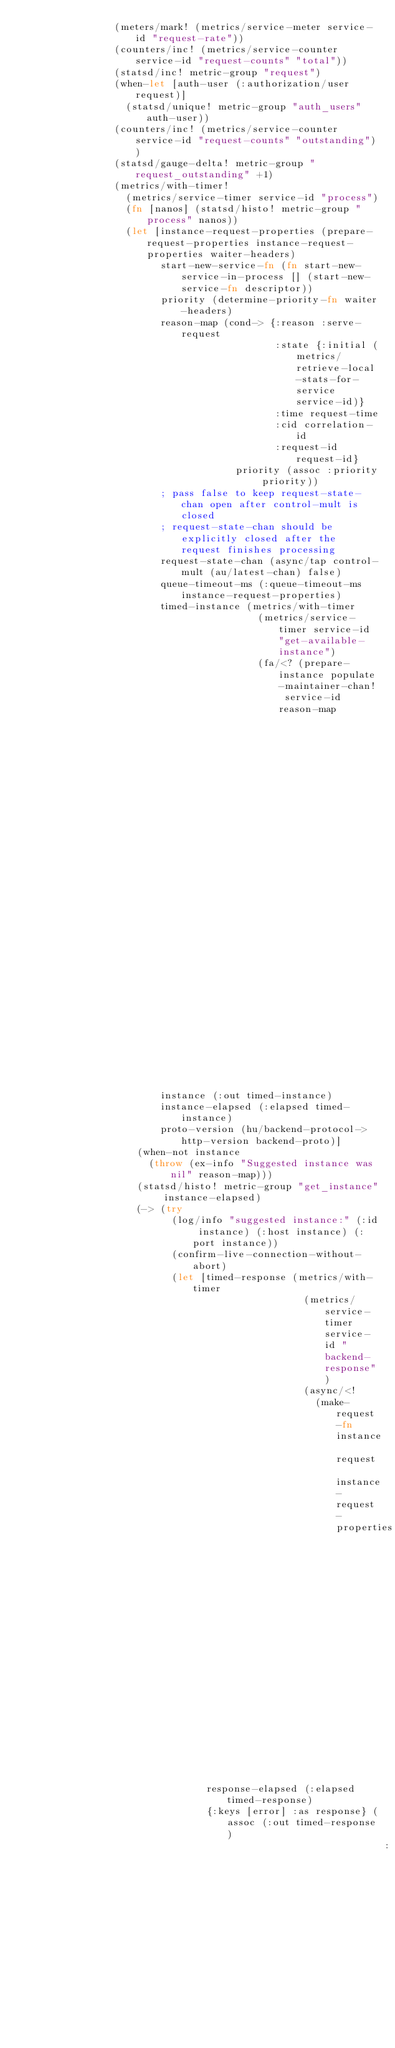<code> <loc_0><loc_0><loc_500><loc_500><_Clojure_>                (meters/mark! (metrics/service-meter service-id "request-rate"))
                (counters/inc! (metrics/service-counter service-id "request-counts" "total"))
                (statsd/inc! metric-group "request")
                (when-let [auth-user (:authorization/user request)]
                  (statsd/unique! metric-group "auth_users" auth-user))
                (counters/inc! (metrics/service-counter service-id "request-counts" "outstanding"))
                (statsd/gauge-delta! metric-group "request_outstanding" +1)
                (metrics/with-timer!
                  (metrics/service-timer service-id "process")
                  (fn [nanos] (statsd/histo! metric-group "process" nanos))
                  (let [instance-request-properties (prepare-request-properties instance-request-properties waiter-headers)
                        start-new-service-fn (fn start-new-service-in-process [] (start-new-service-fn descriptor))
                        priority (determine-priority-fn waiter-headers)
                        reason-map (cond-> {:reason :serve-request
                                            :state {:initial (metrics/retrieve-local-stats-for-service service-id)}
                                            :time request-time
                                            :cid correlation-id
                                            :request-id request-id}
                                     priority (assoc :priority priority))
                        ; pass false to keep request-state-chan open after control-mult is closed
                        ; request-state-chan should be explicitly closed after the request finishes processing
                        request-state-chan (async/tap control-mult (au/latest-chan) false)
                        queue-timeout-ms (:queue-timeout-ms instance-request-properties)
                        timed-instance (metrics/with-timer
                                         (metrics/service-timer service-id "get-available-instance")
                                         (fa/<? (prepare-instance populate-maintainer-chan! service-id reason-map
                                                                  start-new-service-fn request-state-chan queue-timeout-ms
                                                                  reservation-status-promise metric-group)))
                        instance (:out timed-instance)
                        instance-elapsed (:elapsed timed-instance)
                        proto-version (hu/backend-protocol->http-version backend-proto)]
                    (when-not instance
                      (throw (ex-info "Suggested instance was nil" reason-map)))
                    (statsd/histo! metric-group "get_instance" instance-elapsed)
                    (-> (try
                          (log/info "suggested instance:" (:id instance) (:host instance) (:port instance))
                          (confirm-live-connection-without-abort)
                          (let [timed-response (metrics/with-timer
                                                 (metrics/service-timer service-id "backend-response")
                                                 (async/<!
                                                   (make-request-fn instance request instance-request-properties
                                                                    passthrough-headers uri metric-group backend-proto proto-version)))
                                response-elapsed (:elapsed timed-response)
                                {:keys [error] :as response} (assoc (:out timed-response)
                                                               :backend-response-latency-ns response-elapsed)]</code> 